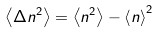Convert formula to latex. <formula><loc_0><loc_0><loc_500><loc_500>\left \langle \Delta n ^ { 2 } \right \rangle = \left \langle n ^ { 2 } \right \rangle - \left \langle n \right \rangle ^ { 2 }</formula> 